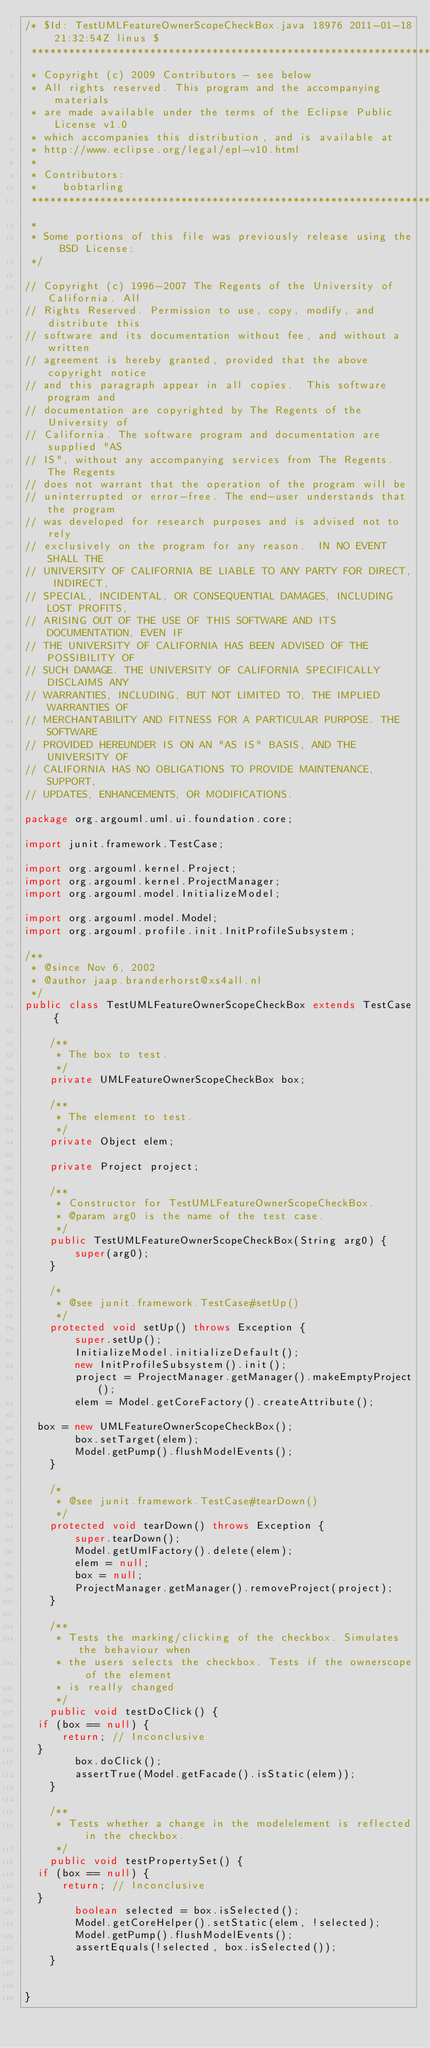Convert code to text. <code><loc_0><loc_0><loc_500><loc_500><_Java_>/* $Id: TestUMLFeatureOwnerScopeCheckBox.java 18976 2011-01-18 21:32:54Z linus $
 *****************************************************************************
 * Copyright (c) 2009 Contributors - see below
 * All rights reserved. This program and the accompanying materials
 * are made available under the terms of the Eclipse Public License v1.0
 * which accompanies this distribution, and is available at
 * http://www.eclipse.org/legal/epl-v10.html
 *
 * Contributors:
 *    bobtarling
 *****************************************************************************
 *
 * Some portions of this file was previously release using the BSD License:
 */

// Copyright (c) 1996-2007 The Regents of the University of California. All
// Rights Reserved. Permission to use, copy, modify, and distribute this
// software and its documentation without fee, and without a written
// agreement is hereby granted, provided that the above copyright notice
// and this paragraph appear in all copies.  This software program and
// documentation are copyrighted by The Regents of the University of
// California. The software program and documentation are supplied "AS
// IS", without any accompanying services from The Regents. The Regents
// does not warrant that the operation of the program will be
// uninterrupted or error-free. The end-user understands that the program
// was developed for research purposes and is advised not to rely
// exclusively on the program for any reason.  IN NO EVENT SHALL THE
// UNIVERSITY OF CALIFORNIA BE LIABLE TO ANY PARTY FOR DIRECT, INDIRECT,
// SPECIAL, INCIDENTAL, OR CONSEQUENTIAL DAMAGES, INCLUDING LOST PROFITS,
// ARISING OUT OF THE USE OF THIS SOFTWARE AND ITS DOCUMENTATION, EVEN IF
// THE UNIVERSITY OF CALIFORNIA HAS BEEN ADVISED OF THE POSSIBILITY OF
// SUCH DAMAGE. THE UNIVERSITY OF CALIFORNIA SPECIFICALLY DISCLAIMS ANY
// WARRANTIES, INCLUDING, BUT NOT LIMITED TO, THE IMPLIED WARRANTIES OF
// MERCHANTABILITY AND FITNESS FOR A PARTICULAR PURPOSE. THE SOFTWARE
// PROVIDED HEREUNDER IS ON AN "AS IS" BASIS, AND THE UNIVERSITY OF
// CALIFORNIA HAS NO OBLIGATIONS TO PROVIDE MAINTENANCE, SUPPORT,
// UPDATES, ENHANCEMENTS, OR MODIFICATIONS.

package org.argouml.uml.ui.foundation.core;

import junit.framework.TestCase;

import org.argouml.kernel.Project;
import org.argouml.kernel.ProjectManager;
import org.argouml.model.InitializeModel;

import org.argouml.model.Model;
import org.argouml.profile.init.InitProfileSubsystem;

/**
 * @since Nov 6, 2002
 * @author jaap.branderhorst@xs4all.nl
 */
public class TestUMLFeatureOwnerScopeCheckBox extends TestCase {

    /**
     * The box to test.
     */
    private UMLFeatureOwnerScopeCheckBox box;

    /**
     * The element to test.
     */
    private Object elem;

    private Project project;

    /**
     * Constructor for TestUMLFeatureOwnerScopeCheckBox.
     * @param arg0 is the name of the test case.
     */
    public TestUMLFeatureOwnerScopeCheckBox(String arg0) {
        super(arg0);
    }

    /*
     * @see junit.framework.TestCase#setUp()
     */
    protected void setUp() throws Exception {
        super.setUp();
        InitializeModel.initializeDefault();
        new InitProfileSubsystem().init();
        project = ProjectManager.getManager().makeEmptyProject(); 
        elem = Model.getCoreFactory().createAttribute();

	box = new UMLFeatureOwnerScopeCheckBox();
        box.setTarget(elem);
        Model.getPump().flushModelEvents();
    }

    /*
     * @see junit.framework.TestCase#tearDown()
     */
    protected void tearDown() throws Exception {
        super.tearDown();
        Model.getUmlFactory().delete(elem);
        elem = null;
        box = null;
        ProjectManager.getManager().removeProject(project);
    }

    /**
     * Tests the marking/clicking of the checkbox. Simulates the behaviour when
     * the users selects the checkbox. Tests if the ownerscope of the element
     * is really changed
     */
    public void testDoClick() {
	if (box == null) {
	    return; // Inconclusive
	}
        box.doClick();
        assertTrue(Model.getFacade().isStatic(elem));
    }

    /**
     * Tests whether a change in the modelelement is reflected in the checkbox.
     */
    public void testPropertySet() {
	if (box == null) {
	    return; // Inconclusive
	}
        boolean selected = box.isSelected();
        Model.getCoreHelper().setStatic(elem, !selected);
        Model.getPump().flushModelEvents();
        assertEquals(!selected, box.isSelected());
    }


}
</code> 